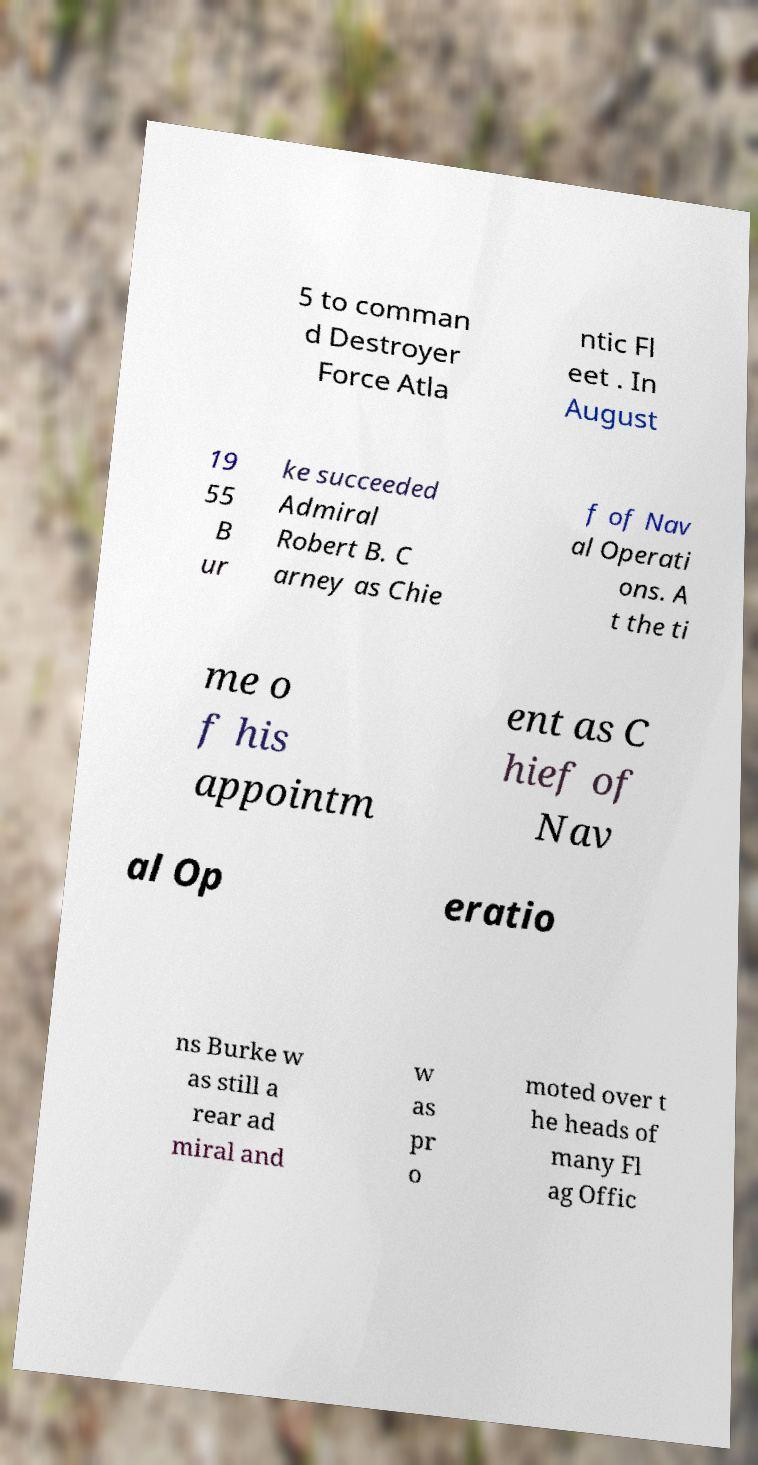For documentation purposes, I need the text within this image transcribed. Could you provide that? 5 to comman d Destroyer Force Atla ntic Fl eet . In August 19 55 B ur ke succeeded Admiral Robert B. C arney as Chie f of Nav al Operati ons. A t the ti me o f his appointm ent as C hief of Nav al Op eratio ns Burke w as still a rear ad miral and w as pr o moted over t he heads of many Fl ag Offic 